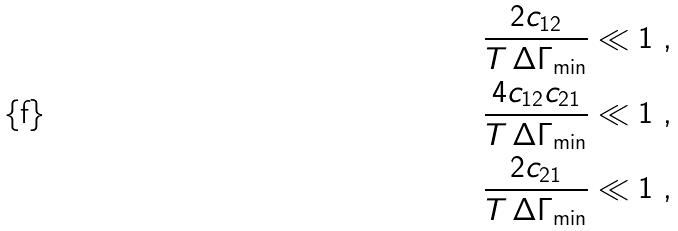<formula> <loc_0><loc_0><loc_500><loc_500>\frac { 2 c _ { 1 2 } } { T \, \Delta \Gamma _ { \min } } & \ll 1 \ , \\ \frac { 4 c _ { 1 2 } c _ { 2 1 } } { T \, \Delta \Gamma _ { \min } } & \ll 1 \ , \\ \frac { 2 c _ { 2 1 } } { T \, \Delta \Gamma _ { \min } } & \ll 1 \ ,</formula> 